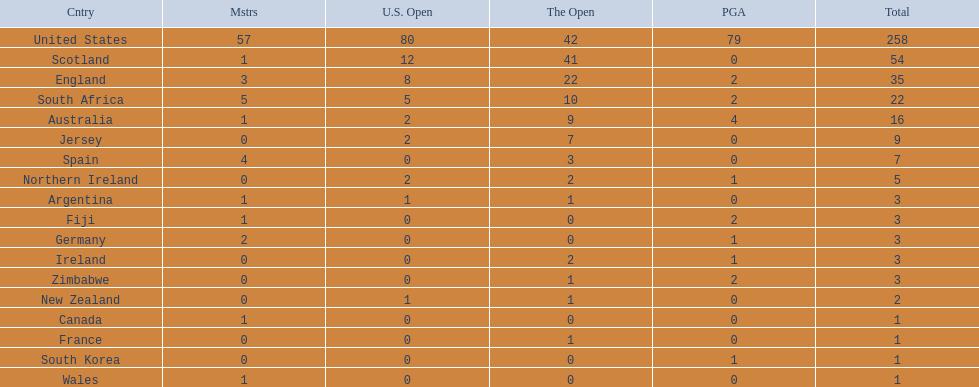How many countries have produced the same number of championship golfers as canada? 3. 